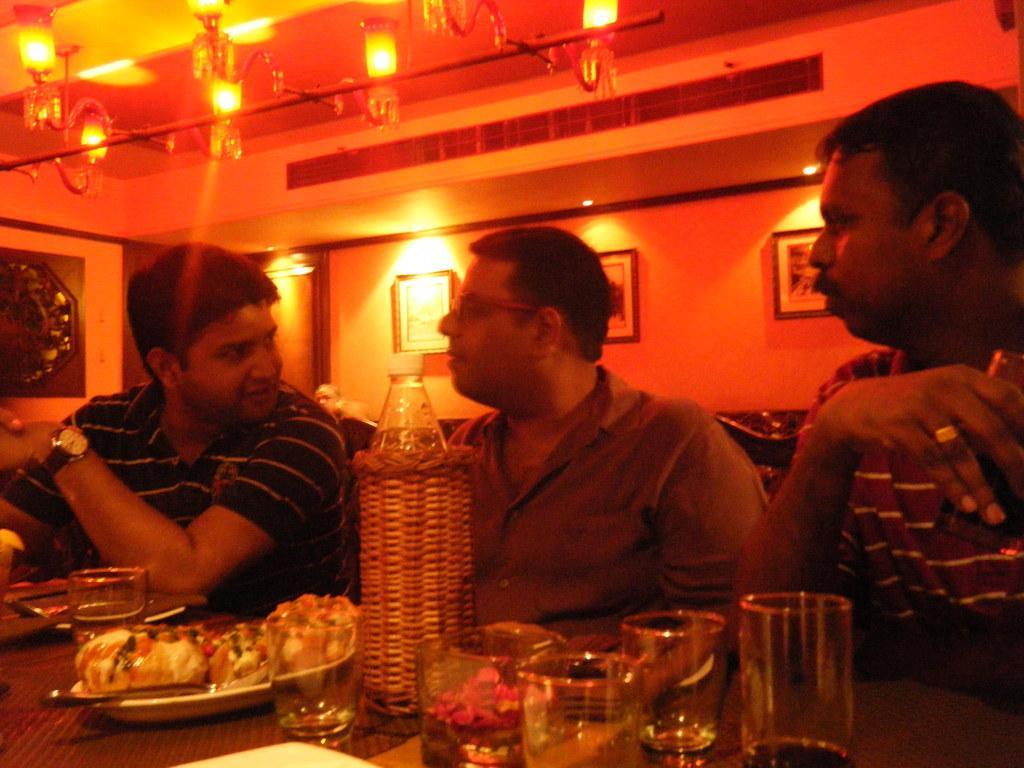How would you summarize this image in a sentence or two? In the image we can see three persons were sitting on the chair around the table. On table,we can see bottle,glasses,plate,tissue paper and food items. In the background there is a wall,lights and photo frame. 